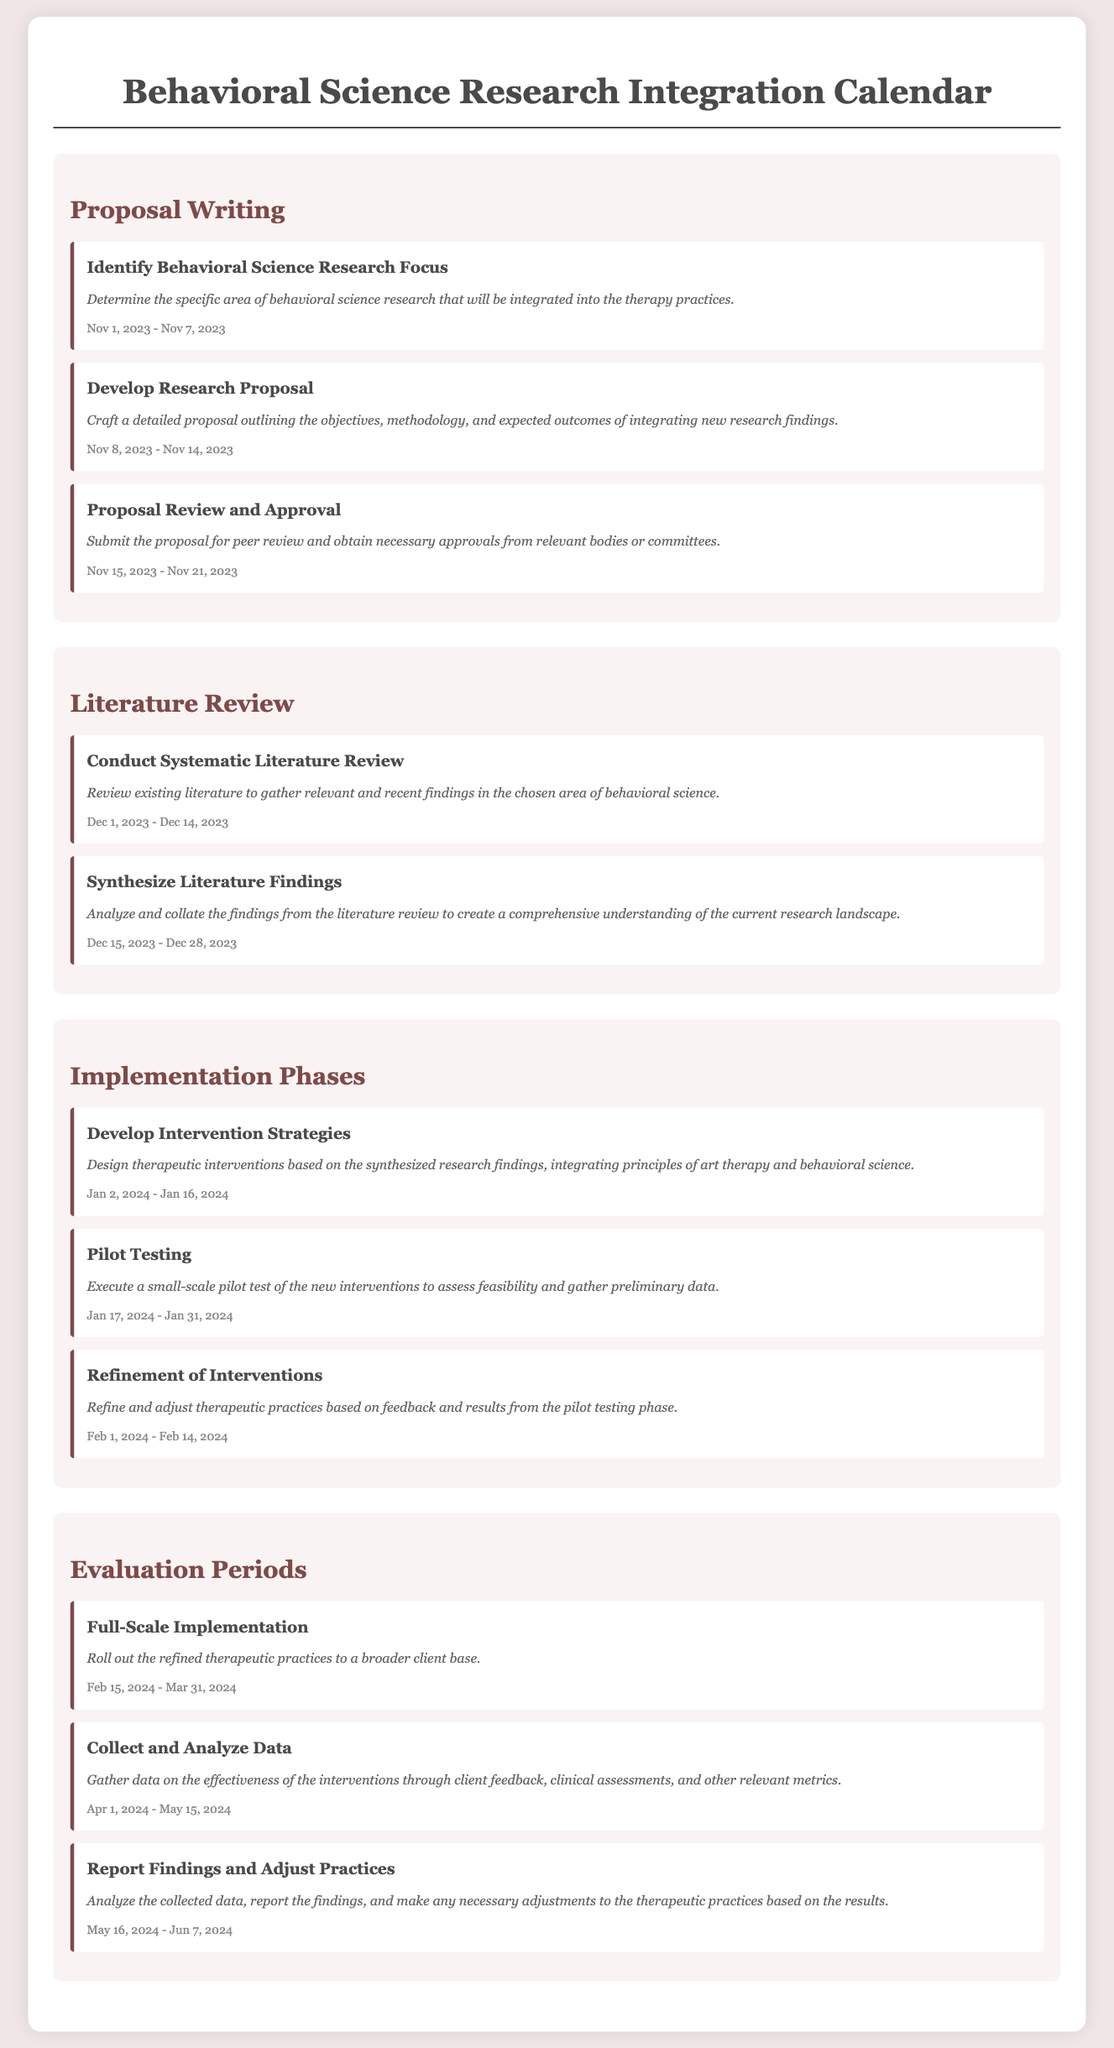What is the start date for identifying behavioral science research focus? The start date for this task is mentioned in the document as November 1, 2023.
Answer: November 1, 2023 What task is performed during the literature review phase? The task conducted during the literature review phase is "Conduct Systematic Literature Review" which involves reviewing existing literature.
Answer: Conduct Systematic Literature Review When does the pilot testing phase start? The document states that the pilot testing phase begins on January 17, 2024.
Answer: January 17, 2024 What is the duration of the full-scale implementation task? The full-scale implementation task lasts from February 15, 2024, to March 31, 2024, indicating its duration.
Answer: February 15, 2024 - March 31, 2024 Which phase involves developing intervention strategies? The phase that involves developing intervention strategies is labeled "Implementation Phases."
Answer: Implementation Phases What is the main focus of the proposal writing phase? The main focus of the proposal writing phase is to outline the objectives, methodology, and expected outcomes.
Answer: Outline objectives, methodology, and expected outcomes How long is the evaluation period for collecting and analyzing data? The duration for collecting and analyzing data is approximately one and a half months.
Answer: April 1, 2024 - May 15, 2024 What type of report findings are made after data collection? After data collection, the type of findings reported is related to the effectiveness of the interventions.
Answer: Effectiveness of the interventions 